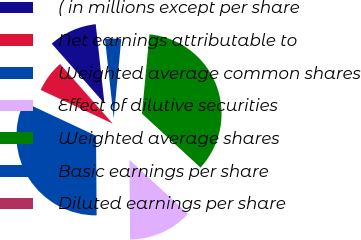Convert chart to OTSL. <chart><loc_0><loc_0><loc_500><loc_500><pie_chart><fcel>( in millions except per share<fcel>Net earnings attributable to<fcel>Weighted average common shares<fcel>Effect of dilutive securities<fcel>Weighted average shares<fcel>Basic earnings per share<fcel>Diluted earnings per share<nl><fcel>9.77%<fcel>6.52%<fcel>32.08%<fcel>13.03%<fcel>35.34%<fcel>3.26%<fcel>0.0%<nl></chart> 